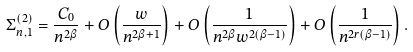<formula> <loc_0><loc_0><loc_500><loc_500>\Sigma _ { n , 1 } ^ { \left ( 2 \right ) } = \frac { C _ { 0 } } { n ^ { 2 \beta } } + O \left ( \frac { w } { n ^ { 2 \beta + 1 } } \right ) + O \left ( \frac { 1 } { n ^ { 2 \beta } w ^ { 2 \left ( \beta - 1 \right ) } } \right ) + O \left ( \frac { 1 } { n ^ { 2 r ( \beta - 1 ) } } \right ) .</formula> 